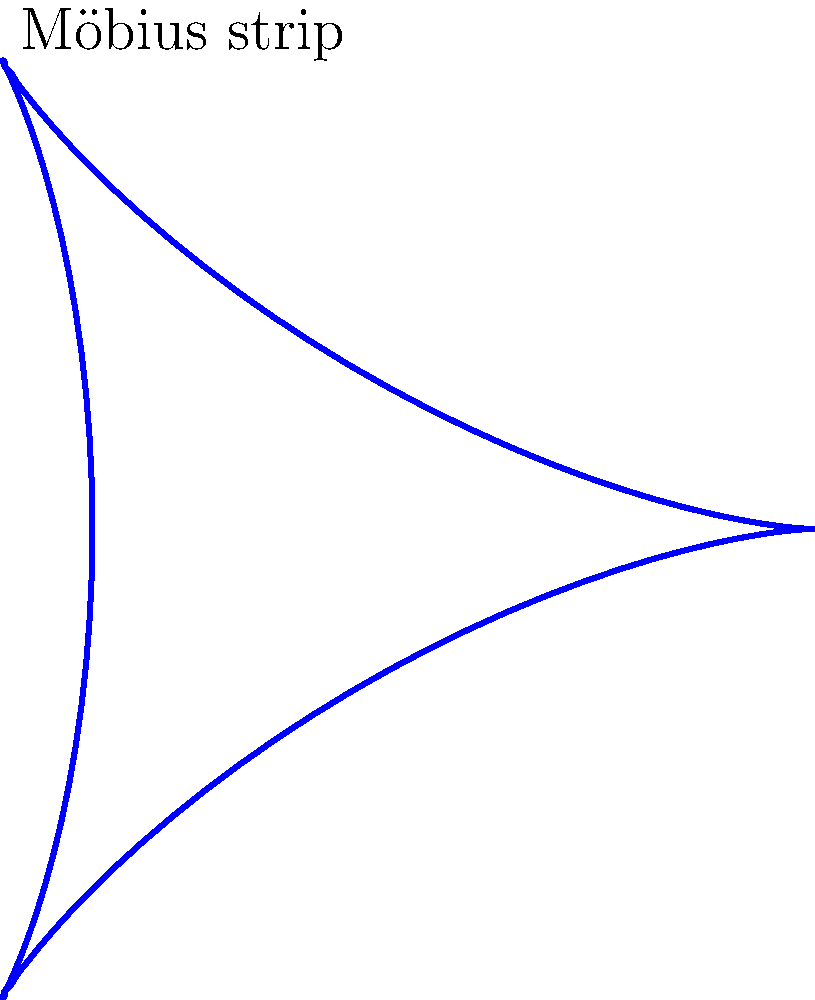Imagine a Möbius strip as a metaphor for the cyclical nature of life and poetry. If you were to write a poem on this strip, starting at one point and continuing until you reach the starting point again, how many revolutions around the strip would you need to make to cover both sides of the surface? To understand this, let's consider the unique properties of a Möbius strip:

1. A Möbius strip is a surface with only one side and one edge.

2. It's created by taking a long rectangular strip and giving it a half-twist before joining the ends.

3. If you start tracing a line on the surface:
   - After one complete revolution, you'll be on the "opposite" side of where you started.
   - After two complete revolutions, you'll return to your starting point.

4. This means that to cover the entire surface:
   - One revolution covers half of the total surface area.
   - Two revolutions are needed to cover the entire surface.

5. In the context of writing a poem:
   - After one revolution, you'd have written on what appears to be one side.
   - After two revolutions, you'd have covered what seems to be both sides, but is actually the entire single surface of the Möbius strip.

Therefore, to write a poem that covers the entire surface of a Möbius strip, returning to the starting point and having written on what appears to be both sides, you would need to make two complete revolutions around the strip.
Answer: Two revolutions 